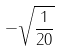Convert formula to latex. <formula><loc_0><loc_0><loc_500><loc_500>- \sqrt { \frac { 1 } { 2 0 } }</formula> 